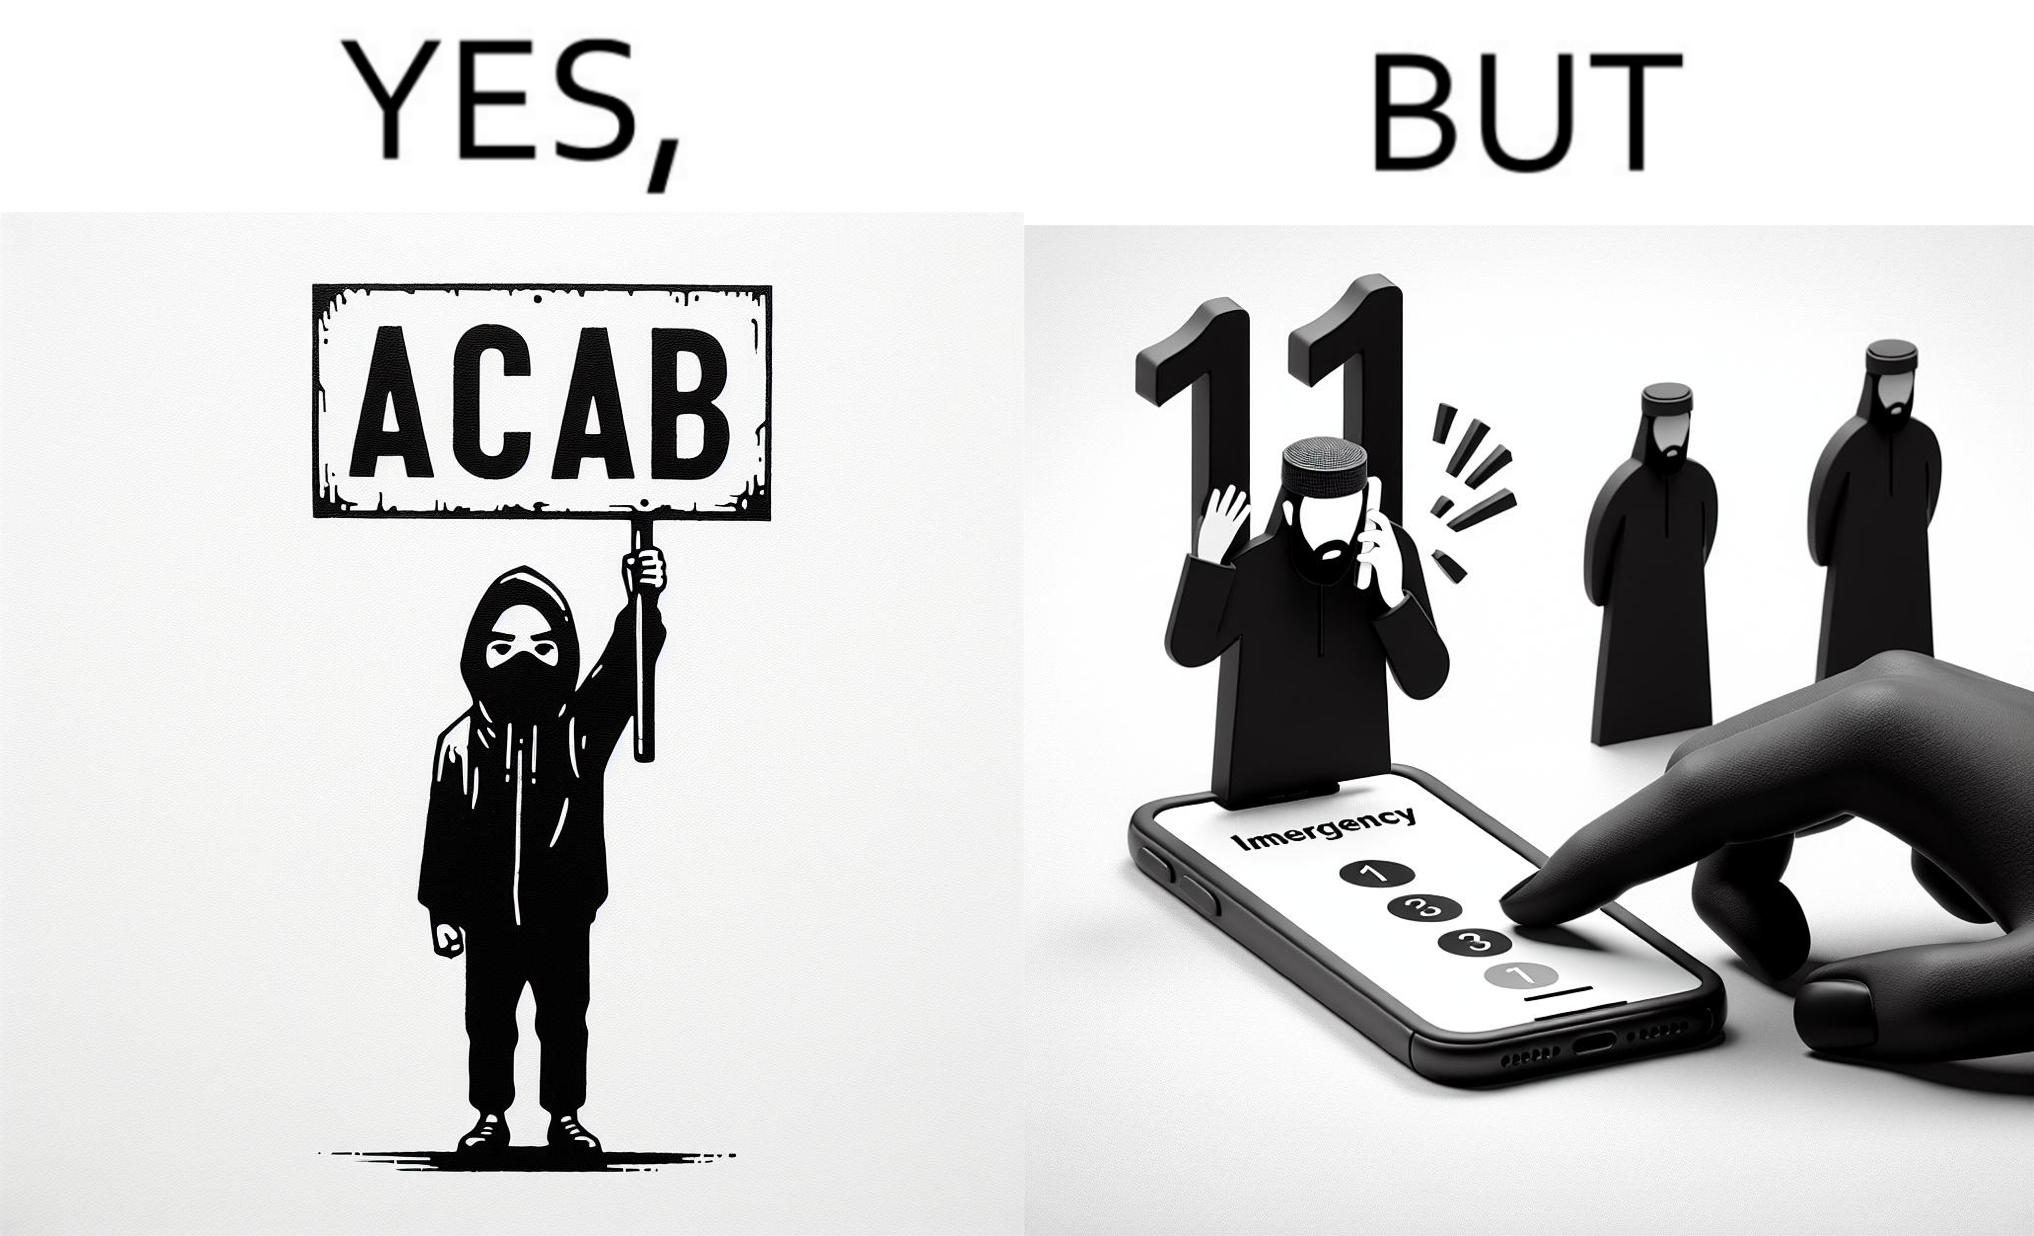What is shown in this image? This is funny because on the one hand this person is rebelling against cops (slogan being All Cops Are Bad - ACAB), but on the other hand they are also calling the cops for help. 